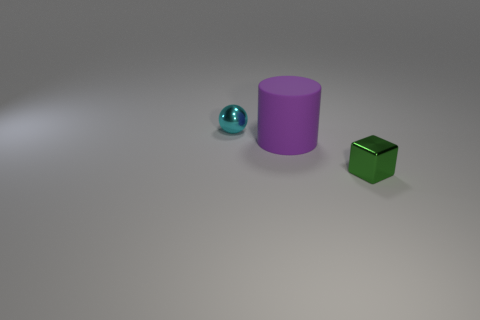Are there any other things that have the same shape as the large matte object?
Your response must be concise. No. How many other things are there of the same size as the green thing?
Make the answer very short. 1. There is a small thing to the left of the shiny object that is to the right of the cyan thing; how many matte things are in front of it?
Make the answer very short. 1. How many small metallic objects are both in front of the small cyan metal thing and behind the small green object?
Ensure brevity in your answer.  0. There is a green metal cube that is in front of the large cylinder; does it have the same size as the metal thing behind the big thing?
Your answer should be very brief. Yes. How many things are metal things behind the tiny green metallic cube or matte cylinders?
Keep it short and to the point. 2. There is a purple thing that is in front of the ball; what material is it?
Your answer should be very brief. Rubber. What is the cylinder made of?
Provide a short and direct response. Rubber. What is the small object left of the metal object that is in front of the tiny object that is behind the big thing made of?
Ensure brevity in your answer.  Metal. Is there any other thing that has the same material as the purple cylinder?
Your answer should be compact. No. 